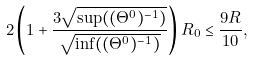<formula> <loc_0><loc_0><loc_500><loc_500>2 \left ( 1 + \frac { 3 \sqrt { \sup ( ( \Theta ^ { 0 } ) ^ { - 1 } ) } } { \sqrt { \inf ( ( \Theta ^ { 0 } ) ^ { - 1 } ) } } \right ) R _ { 0 } \leq \frac { 9 R } { 1 0 } ,</formula> 